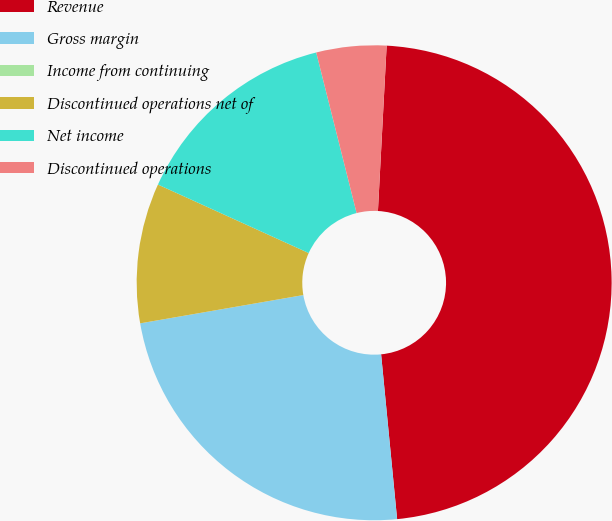<chart> <loc_0><loc_0><loc_500><loc_500><pie_chart><fcel>Revenue<fcel>Gross margin<fcel>Income from continuing<fcel>Discontinued operations net of<fcel>Net income<fcel>Discontinued operations<nl><fcel>47.62%<fcel>23.81%<fcel>0.0%<fcel>9.52%<fcel>14.29%<fcel>4.76%<nl></chart> 